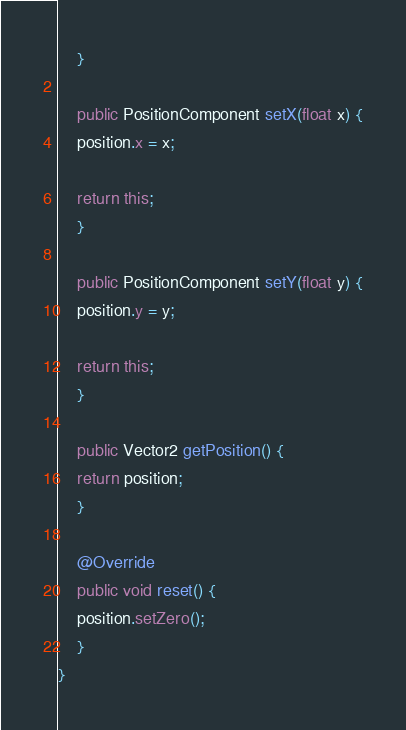Convert code to text. <code><loc_0><loc_0><loc_500><loc_500><_Java_>    }

    public PositionComponent setX(float x) {
	position.x = x;

	return this;
    }

    public PositionComponent setY(float y) {
	position.y = y;

	return this;
    }

    public Vector2 getPosition() {
	return position;
    }

    @Override
    public void reset() {
	position.setZero();
    }
}</code> 